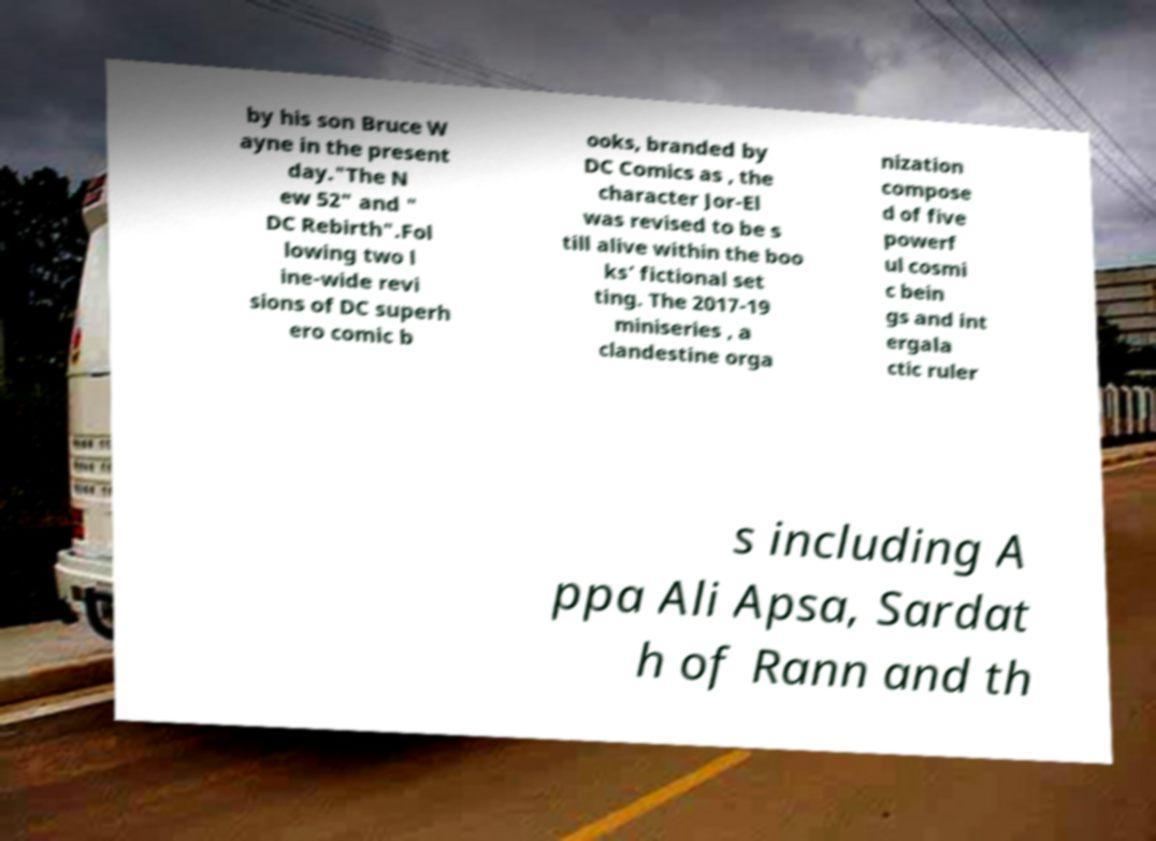Can you read and provide the text displayed in the image?This photo seems to have some interesting text. Can you extract and type it out for me? by his son Bruce W ayne in the present day."The N ew 52" and " DC Rebirth".Fol lowing two l ine-wide revi sions of DC superh ero comic b ooks, branded by DC Comics as , the character Jor-El was revised to be s till alive within the boo ks’ fictional set ting. The 2017-19 miniseries , a clandestine orga nization compose d of five powerf ul cosmi c bein gs and int ergala ctic ruler s including A ppa Ali Apsa, Sardat h of Rann and th 